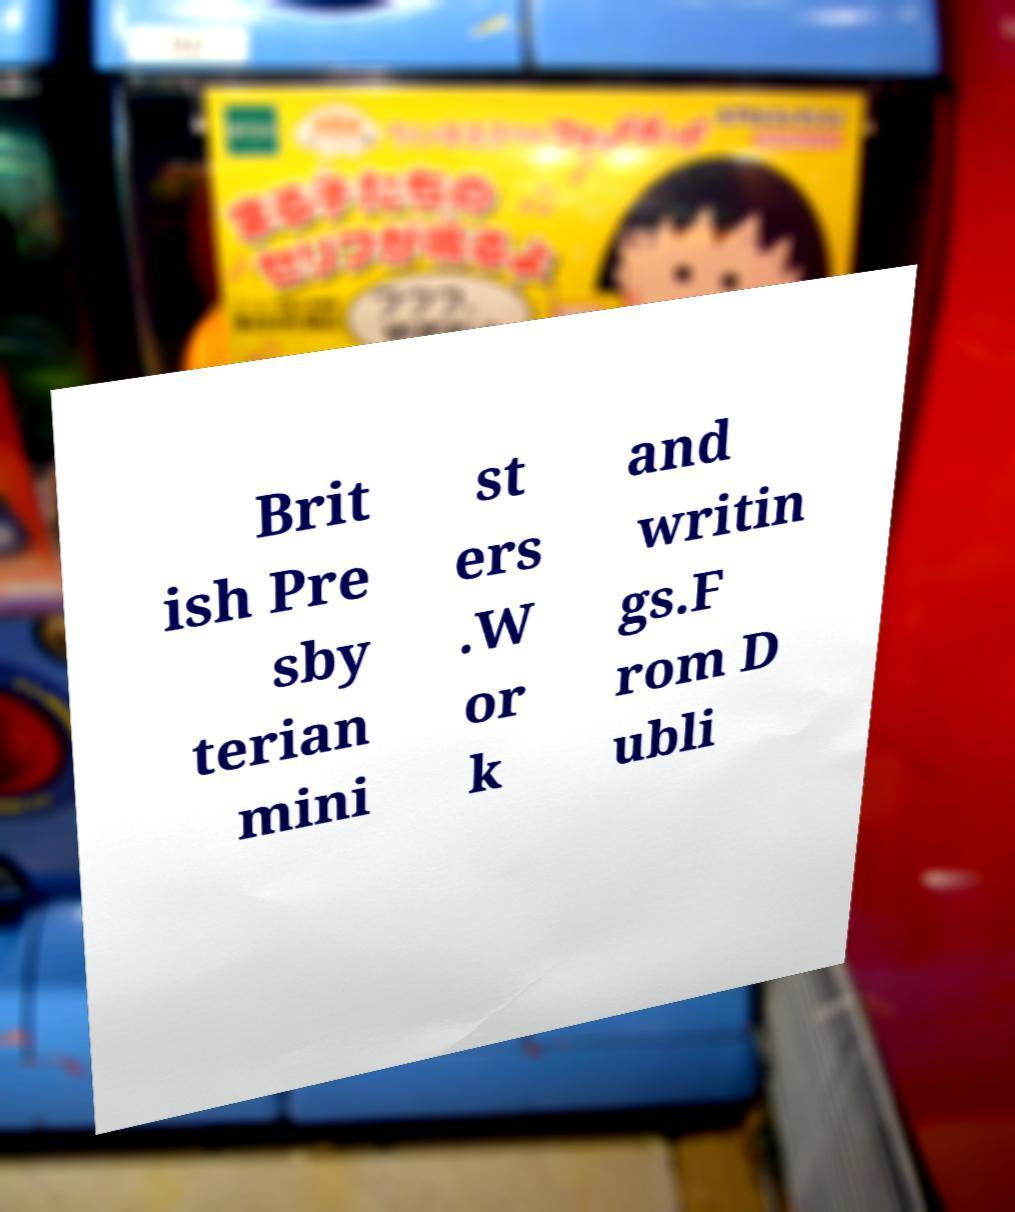Can you accurately transcribe the text from the provided image for me? Brit ish Pre sby terian mini st ers .W or k and writin gs.F rom D ubli 